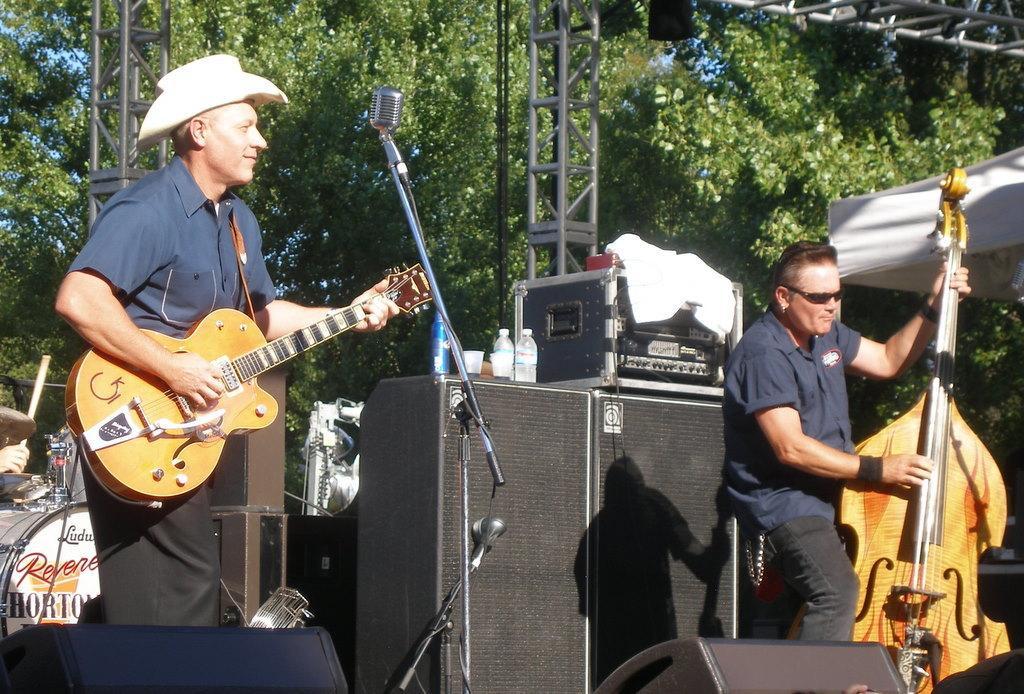Describe this image in one or two sentences. In this picture we can see two persons standing and playing guitar. He wear a cap and he has goggles. And in the background we can see some musical instruments. And these are the trees. 